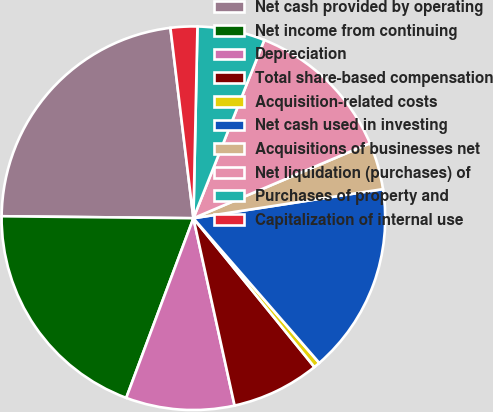<chart> <loc_0><loc_0><loc_500><loc_500><pie_chart><fcel>Net cash provided by operating<fcel>Net income from continuing<fcel>Depreciation<fcel>Total share-based compensation<fcel>Acquisition-related costs<fcel>Net cash used in investing<fcel>Acquisitions of businesses net<fcel>Net liquidation (purchases) of<fcel>Purchases of property and<fcel>Capitalization of internal use<nl><fcel>22.92%<fcel>19.47%<fcel>9.14%<fcel>7.42%<fcel>0.53%<fcel>16.03%<fcel>3.97%<fcel>12.58%<fcel>5.69%<fcel>2.25%<nl></chart> 